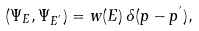Convert formula to latex. <formula><loc_0><loc_0><loc_500><loc_500>( \Psi _ { E } , \Psi _ { E ^ { ^ { \prime } } } ) = w ( E ) \, \delta ( p - p ^ { ^ { \prime } } ) ,</formula> 